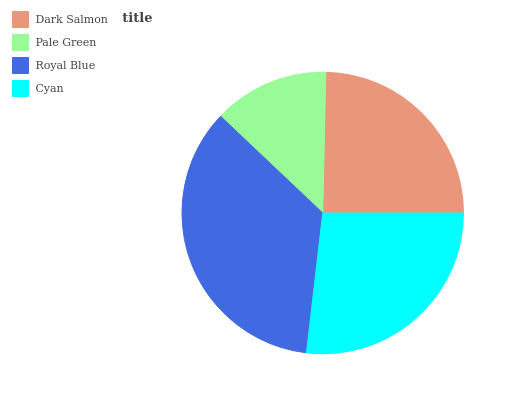Is Pale Green the minimum?
Answer yes or no. Yes. Is Royal Blue the maximum?
Answer yes or no. Yes. Is Royal Blue the minimum?
Answer yes or no. No. Is Pale Green the maximum?
Answer yes or no. No. Is Royal Blue greater than Pale Green?
Answer yes or no. Yes. Is Pale Green less than Royal Blue?
Answer yes or no. Yes. Is Pale Green greater than Royal Blue?
Answer yes or no. No. Is Royal Blue less than Pale Green?
Answer yes or no. No. Is Cyan the high median?
Answer yes or no. Yes. Is Dark Salmon the low median?
Answer yes or no. Yes. Is Dark Salmon the high median?
Answer yes or no. No. Is Royal Blue the low median?
Answer yes or no. No. 